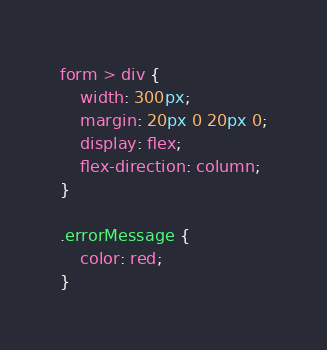Convert code to text. <code><loc_0><loc_0><loc_500><loc_500><_CSS_>form > div {
    width: 300px;
    margin: 20px 0 20px 0;
    display: flex;
    flex-direction: column;
}

.errorMessage {
    color: red;
}</code> 